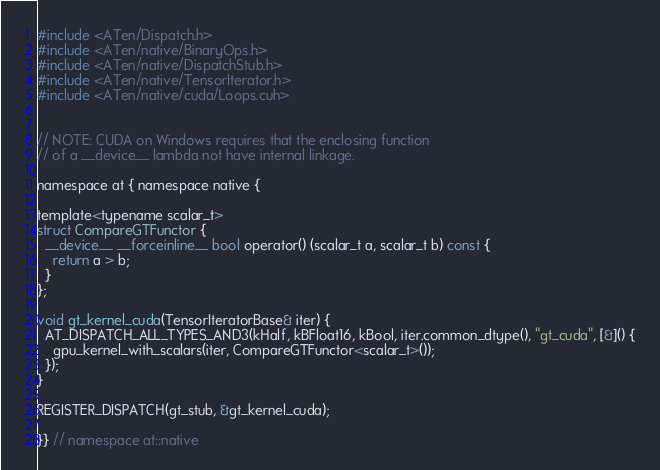Convert code to text. <code><loc_0><loc_0><loc_500><loc_500><_Cuda_>#include <ATen/Dispatch.h>
#include <ATen/native/BinaryOps.h>
#include <ATen/native/DispatchStub.h>
#include <ATen/native/TensorIterator.h>
#include <ATen/native/cuda/Loops.cuh>


// NOTE: CUDA on Windows requires that the enclosing function
// of a __device__ lambda not have internal linkage.

namespace at { namespace native {

template<typename scalar_t>
struct CompareGTFunctor {
  __device__ __forceinline__ bool operator() (scalar_t a, scalar_t b) const {
    return a > b;
  }
};

void gt_kernel_cuda(TensorIteratorBase& iter) {
  AT_DISPATCH_ALL_TYPES_AND3(kHalf, kBFloat16, kBool, iter.common_dtype(), "gt_cuda", [&]() {
    gpu_kernel_with_scalars(iter, CompareGTFunctor<scalar_t>());
  });
}

REGISTER_DISPATCH(gt_stub, &gt_kernel_cuda);

}} // namespace at::native
</code> 